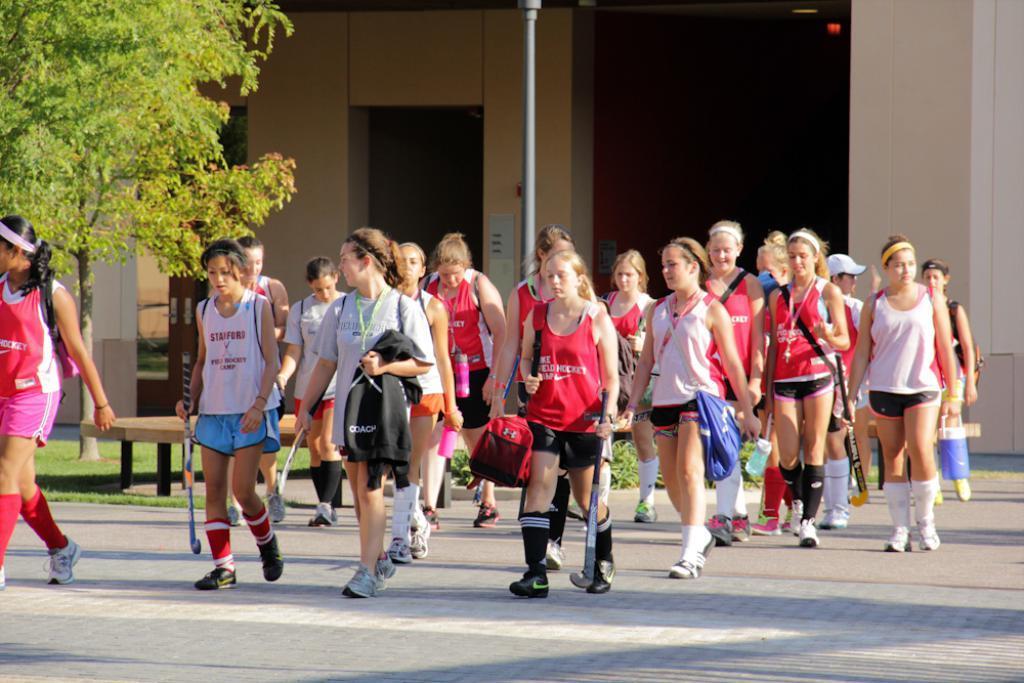In one or two sentences, can you explain what this image depicts? In this image we can see group of people walking on the ground ,some women are holding hockey sticks and some containers in their hands. In the left side of the image we can see a bench , a tree and grass. At the top of the image we can see a building with doors, pole and some lights on the roof. 